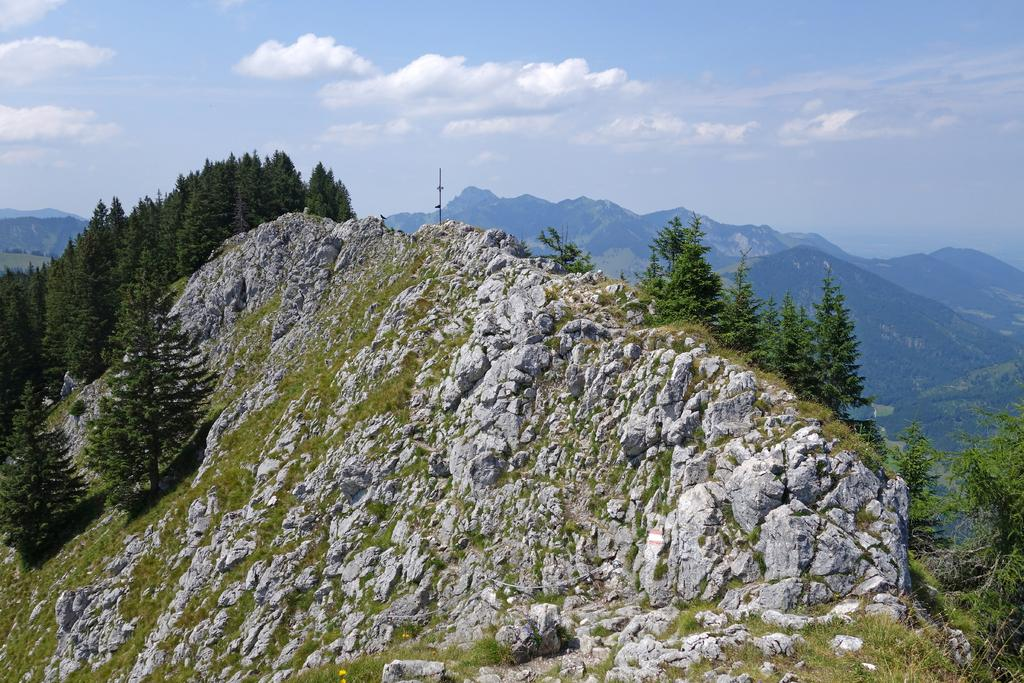What is located in the center of the image? There are trees, rocks, grass, and mountains in the center of the image. What type of vegetation can be seen in the image? Trees and grass are present in the image. What geological features are visible in the image? Rocks and mountains are visible in the image. What is visible in the sky at the top of the image? Clouds are present in the sky at the top of the image. What type of neck injury can be seen on the mountain in the image? There is no neck injury present in the image; it features trees, rocks, grass, and mountains. What type of protest is taking place in the image? There is no protest present in the image; it features trees, rocks, grass, and mountains. 